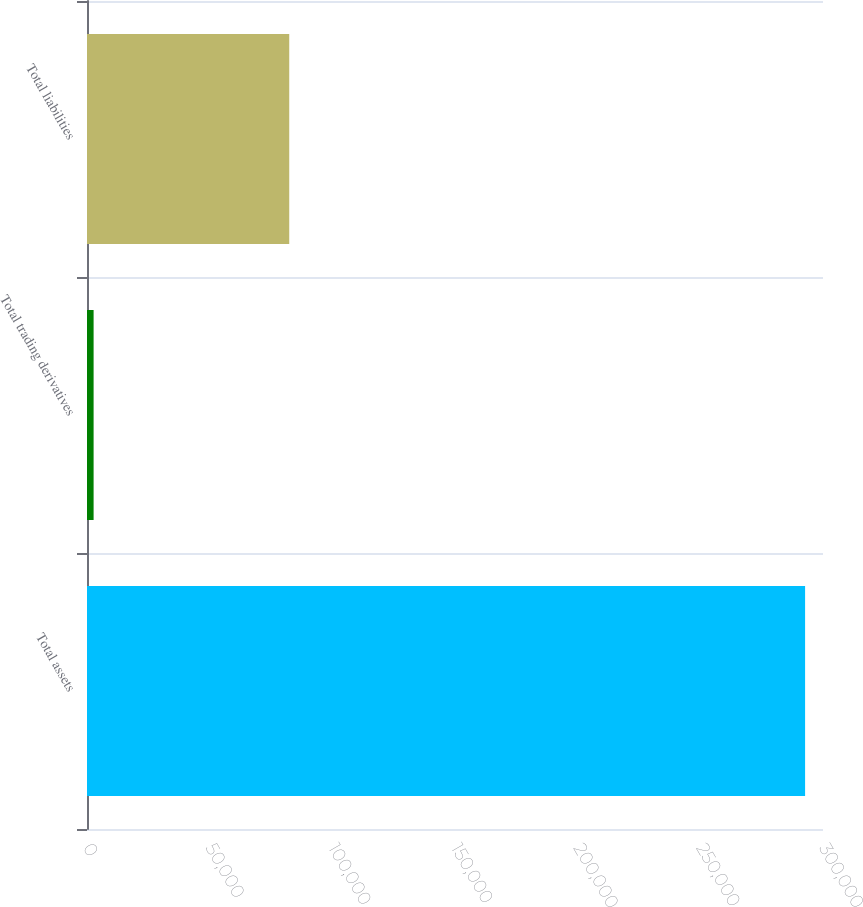Convert chart. <chart><loc_0><loc_0><loc_500><loc_500><bar_chart><fcel>Total assets<fcel>Total trading derivatives<fcel>Total liabilities<nl><fcel>292700<fcel>2691<fcel>82437<nl></chart> 